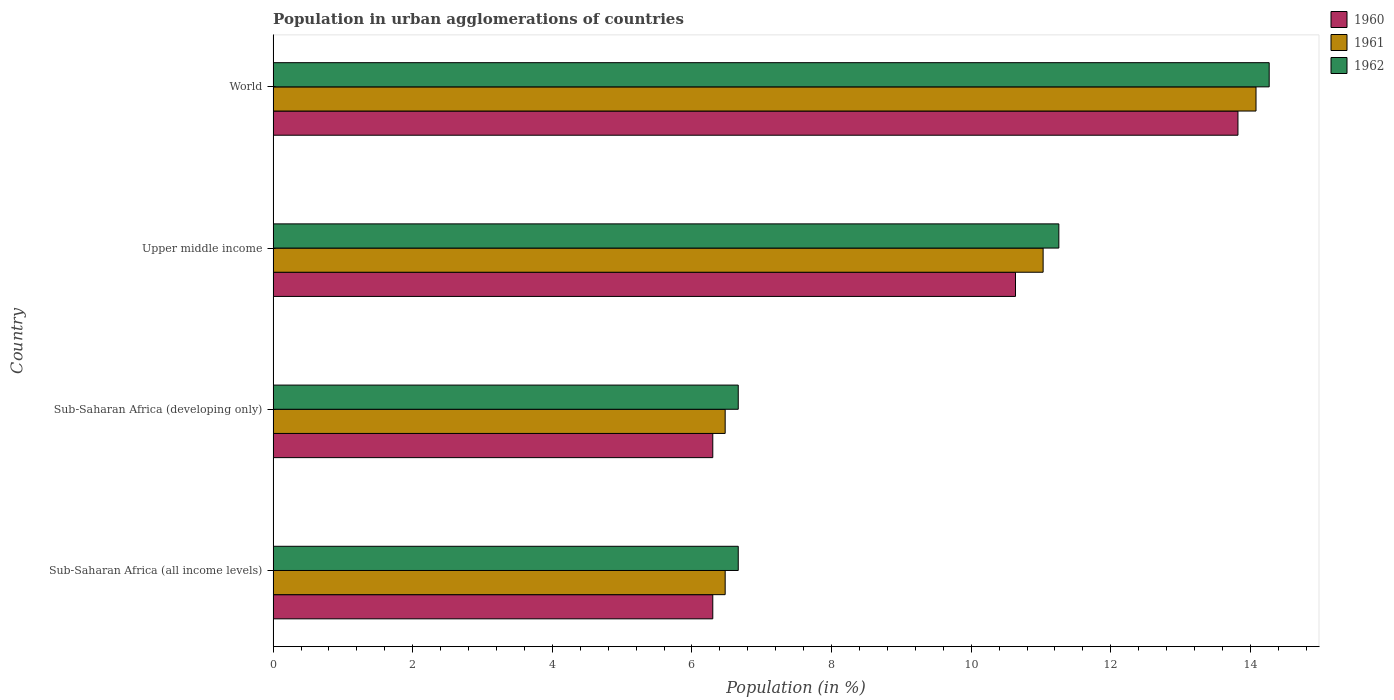How many different coloured bars are there?
Give a very brief answer. 3. How many groups of bars are there?
Ensure brevity in your answer.  4. Are the number of bars per tick equal to the number of legend labels?
Your answer should be very brief. Yes. How many bars are there on the 2nd tick from the top?
Offer a very short reply. 3. What is the label of the 4th group of bars from the top?
Give a very brief answer. Sub-Saharan Africa (all income levels). What is the percentage of population in urban agglomerations in 1961 in Sub-Saharan Africa (all income levels)?
Your answer should be compact. 6.48. Across all countries, what is the maximum percentage of population in urban agglomerations in 1961?
Ensure brevity in your answer.  14.08. Across all countries, what is the minimum percentage of population in urban agglomerations in 1960?
Provide a short and direct response. 6.3. In which country was the percentage of population in urban agglomerations in 1960 minimum?
Your answer should be compact. Sub-Saharan Africa (all income levels). What is the total percentage of population in urban agglomerations in 1961 in the graph?
Your response must be concise. 38.06. What is the difference between the percentage of population in urban agglomerations in 1961 in Sub-Saharan Africa (developing only) and that in Upper middle income?
Provide a short and direct response. -4.55. What is the difference between the percentage of population in urban agglomerations in 1961 in Upper middle income and the percentage of population in urban agglomerations in 1962 in Sub-Saharan Africa (all income levels)?
Your response must be concise. 4.37. What is the average percentage of population in urban agglomerations in 1962 per country?
Give a very brief answer. 9.71. What is the difference between the percentage of population in urban agglomerations in 1960 and percentage of population in urban agglomerations in 1962 in World?
Offer a terse response. -0.45. In how many countries, is the percentage of population in urban agglomerations in 1962 greater than 6.8 %?
Provide a succinct answer. 2. What is the ratio of the percentage of population in urban agglomerations in 1960 in Sub-Saharan Africa (all income levels) to that in Upper middle income?
Keep it short and to the point. 0.59. Is the difference between the percentage of population in urban agglomerations in 1960 in Sub-Saharan Africa (developing only) and World greater than the difference between the percentage of population in urban agglomerations in 1962 in Sub-Saharan Africa (developing only) and World?
Keep it short and to the point. Yes. What is the difference between the highest and the second highest percentage of population in urban agglomerations in 1961?
Ensure brevity in your answer.  3.05. What is the difference between the highest and the lowest percentage of population in urban agglomerations in 1961?
Make the answer very short. 7.6. Is it the case that in every country, the sum of the percentage of population in urban agglomerations in 1962 and percentage of population in urban agglomerations in 1960 is greater than the percentage of population in urban agglomerations in 1961?
Give a very brief answer. Yes. Are all the bars in the graph horizontal?
Keep it short and to the point. Yes. How many countries are there in the graph?
Make the answer very short. 4. Does the graph contain any zero values?
Offer a terse response. No. Does the graph contain grids?
Offer a very short reply. No. Where does the legend appear in the graph?
Provide a succinct answer. Top right. How many legend labels are there?
Provide a succinct answer. 3. How are the legend labels stacked?
Give a very brief answer. Vertical. What is the title of the graph?
Offer a terse response. Population in urban agglomerations of countries. Does "1979" appear as one of the legend labels in the graph?
Give a very brief answer. No. What is the label or title of the X-axis?
Give a very brief answer. Population (in %). What is the label or title of the Y-axis?
Your answer should be very brief. Country. What is the Population (in %) in 1960 in Sub-Saharan Africa (all income levels)?
Keep it short and to the point. 6.3. What is the Population (in %) of 1961 in Sub-Saharan Africa (all income levels)?
Provide a short and direct response. 6.48. What is the Population (in %) of 1962 in Sub-Saharan Africa (all income levels)?
Make the answer very short. 6.66. What is the Population (in %) in 1960 in Sub-Saharan Africa (developing only)?
Give a very brief answer. 6.3. What is the Population (in %) in 1961 in Sub-Saharan Africa (developing only)?
Your response must be concise. 6.48. What is the Population (in %) in 1962 in Sub-Saharan Africa (developing only)?
Provide a succinct answer. 6.66. What is the Population (in %) in 1960 in Upper middle income?
Provide a succinct answer. 10.63. What is the Population (in %) in 1961 in Upper middle income?
Ensure brevity in your answer.  11.03. What is the Population (in %) of 1962 in Upper middle income?
Offer a terse response. 11.26. What is the Population (in %) of 1960 in World?
Provide a succinct answer. 13.82. What is the Population (in %) of 1961 in World?
Make the answer very short. 14.08. What is the Population (in %) of 1962 in World?
Your answer should be very brief. 14.27. Across all countries, what is the maximum Population (in %) of 1960?
Your answer should be very brief. 13.82. Across all countries, what is the maximum Population (in %) of 1961?
Provide a short and direct response. 14.08. Across all countries, what is the maximum Population (in %) of 1962?
Provide a short and direct response. 14.27. Across all countries, what is the minimum Population (in %) of 1960?
Your response must be concise. 6.3. Across all countries, what is the minimum Population (in %) of 1961?
Provide a succinct answer. 6.48. Across all countries, what is the minimum Population (in %) of 1962?
Make the answer very short. 6.66. What is the total Population (in %) in 1960 in the graph?
Provide a succinct answer. 37.05. What is the total Population (in %) of 1961 in the graph?
Keep it short and to the point. 38.06. What is the total Population (in %) in 1962 in the graph?
Make the answer very short. 38.85. What is the difference between the Population (in %) in 1961 in Sub-Saharan Africa (all income levels) and that in Sub-Saharan Africa (developing only)?
Give a very brief answer. 0. What is the difference between the Population (in %) in 1962 in Sub-Saharan Africa (all income levels) and that in Sub-Saharan Africa (developing only)?
Ensure brevity in your answer.  0. What is the difference between the Population (in %) in 1960 in Sub-Saharan Africa (all income levels) and that in Upper middle income?
Ensure brevity in your answer.  -4.34. What is the difference between the Population (in %) in 1961 in Sub-Saharan Africa (all income levels) and that in Upper middle income?
Provide a short and direct response. -4.55. What is the difference between the Population (in %) of 1962 in Sub-Saharan Africa (all income levels) and that in Upper middle income?
Provide a succinct answer. -4.59. What is the difference between the Population (in %) of 1960 in Sub-Saharan Africa (all income levels) and that in World?
Provide a succinct answer. -7.52. What is the difference between the Population (in %) of 1961 in Sub-Saharan Africa (all income levels) and that in World?
Your answer should be very brief. -7.6. What is the difference between the Population (in %) of 1962 in Sub-Saharan Africa (all income levels) and that in World?
Keep it short and to the point. -7.61. What is the difference between the Population (in %) in 1960 in Sub-Saharan Africa (developing only) and that in Upper middle income?
Provide a succinct answer. -4.34. What is the difference between the Population (in %) of 1961 in Sub-Saharan Africa (developing only) and that in Upper middle income?
Provide a succinct answer. -4.55. What is the difference between the Population (in %) of 1962 in Sub-Saharan Africa (developing only) and that in Upper middle income?
Ensure brevity in your answer.  -4.59. What is the difference between the Population (in %) of 1960 in Sub-Saharan Africa (developing only) and that in World?
Offer a terse response. -7.52. What is the difference between the Population (in %) of 1961 in Sub-Saharan Africa (developing only) and that in World?
Your answer should be very brief. -7.6. What is the difference between the Population (in %) of 1962 in Sub-Saharan Africa (developing only) and that in World?
Your answer should be very brief. -7.61. What is the difference between the Population (in %) of 1960 in Upper middle income and that in World?
Provide a short and direct response. -3.19. What is the difference between the Population (in %) of 1961 in Upper middle income and that in World?
Keep it short and to the point. -3.05. What is the difference between the Population (in %) of 1962 in Upper middle income and that in World?
Offer a very short reply. -3.01. What is the difference between the Population (in %) of 1960 in Sub-Saharan Africa (all income levels) and the Population (in %) of 1961 in Sub-Saharan Africa (developing only)?
Provide a succinct answer. -0.18. What is the difference between the Population (in %) in 1960 in Sub-Saharan Africa (all income levels) and the Population (in %) in 1962 in Sub-Saharan Africa (developing only)?
Offer a terse response. -0.36. What is the difference between the Population (in %) of 1961 in Sub-Saharan Africa (all income levels) and the Population (in %) of 1962 in Sub-Saharan Africa (developing only)?
Offer a very short reply. -0.19. What is the difference between the Population (in %) in 1960 in Sub-Saharan Africa (all income levels) and the Population (in %) in 1961 in Upper middle income?
Give a very brief answer. -4.73. What is the difference between the Population (in %) of 1960 in Sub-Saharan Africa (all income levels) and the Population (in %) of 1962 in Upper middle income?
Make the answer very short. -4.96. What is the difference between the Population (in %) in 1961 in Sub-Saharan Africa (all income levels) and the Population (in %) in 1962 in Upper middle income?
Your answer should be very brief. -4.78. What is the difference between the Population (in %) of 1960 in Sub-Saharan Africa (all income levels) and the Population (in %) of 1961 in World?
Offer a very short reply. -7.78. What is the difference between the Population (in %) of 1960 in Sub-Saharan Africa (all income levels) and the Population (in %) of 1962 in World?
Your response must be concise. -7.97. What is the difference between the Population (in %) in 1961 in Sub-Saharan Africa (all income levels) and the Population (in %) in 1962 in World?
Offer a terse response. -7.79. What is the difference between the Population (in %) in 1960 in Sub-Saharan Africa (developing only) and the Population (in %) in 1961 in Upper middle income?
Your response must be concise. -4.73. What is the difference between the Population (in %) in 1960 in Sub-Saharan Africa (developing only) and the Population (in %) in 1962 in Upper middle income?
Provide a short and direct response. -4.96. What is the difference between the Population (in %) of 1961 in Sub-Saharan Africa (developing only) and the Population (in %) of 1962 in Upper middle income?
Keep it short and to the point. -4.78. What is the difference between the Population (in %) in 1960 in Sub-Saharan Africa (developing only) and the Population (in %) in 1961 in World?
Give a very brief answer. -7.78. What is the difference between the Population (in %) of 1960 in Sub-Saharan Africa (developing only) and the Population (in %) of 1962 in World?
Provide a short and direct response. -7.97. What is the difference between the Population (in %) in 1961 in Sub-Saharan Africa (developing only) and the Population (in %) in 1962 in World?
Offer a very short reply. -7.79. What is the difference between the Population (in %) of 1960 in Upper middle income and the Population (in %) of 1961 in World?
Provide a short and direct response. -3.45. What is the difference between the Population (in %) in 1960 in Upper middle income and the Population (in %) in 1962 in World?
Ensure brevity in your answer.  -3.63. What is the difference between the Population (in %) in 1961 in Upper middle income and the Population (in %) in 1962 in World?
Ensure brevity in your answer.  -3.24. What is the average Population (in %) of 1960 per country?
Ensure brevity in your answer.  9.26. What is the average Population (in %) of 1961 per country?
Your response must be concise. 9.52. What is the average Population (in %) in 1962 per country?
Ensure brevity in your answer.  9.71. What is the difference between the Population (in %) in 1960 and Population (in %) in 1961 in Sub-Saharan Africa (all income levels)?
Give a very brief answer. -0.18. What is the difference between the Population (in %) in 1960 and Population (in %) in 1962 in Sub-Saharan Africa (all income levels)?
Offer a terse response. -0.36. What is the difference between the Population (in %) in 1961 and Population (in %) in 1962 in Sub-Saharan Africa (all income levels)?
Offer a very short reply. -0.19. What is the difference between the Population (in %) in 1960 and Population (in %) in 1961 in Sub-Saharan Africa (developing only)?
Offer a very short reply. -0.18. What is the difference between the Population (in %) of 1960 and Population (in %) of 1962 in Sub-Saharan Africa (developing only)?
Keep it short and to the point. -0.36. What is the difference between the Population (in %) in 1961 and Population (in %) in 1962 in Sub-Saharan Africa (developing only)?
Your response must be concise. -0.19. What is the difference between the Population (in %) of 1960 and Population (in %) of 1961 in Upper middle income?
Provide a short and direct response. -0.4. What is the difference between the Population (in %) of 1960 and Population (in %) of 1962 in Upper middle income?
Provide a short and direct response. -0.62. What is the difference between the Population (in %) in 1961 and Population (in %) in 1962 in Upper middle income?
Your response must be concise. -0.23. What is the difference between the Population (in %) of 1960 and Population (in %) of 1961 in World?
Your answer should be compact. -0.26. What is the difference between the Population (in %) in 1960 and Population (in %) in 1962 in World?
Give a very brief answer. -0.45. What is the difference between the Population (in %) in 1961 and Population (in %) in 1962 in World?
Provide a succinct answer. -0.19. What is the ratio of the Population (in %) in 1960 in Sub-Saharan Africa (all income levels) to that in Sub-Saharan Africa (developing only)?
Your response must be concise. 1. What is the ratio of the Population (in %) in 1960 in Sub-Saharan Africa (all income levels) to that in Upper middle income?
Your response must be concise. 0.59. What is the ratio of the Population (in %) of 1961 in Sub-Saharan Africa (all income levels) to that in Upper middle income?
Provide a succinct answer. 0.59. What is the ratio of the Population (in %) of 1962 in Sub-Saharan Africa (all income levels) to that in Upper middle income?
Ensure brevity in your answer.  0.59. What is the ratio of the Population (in %) in 1960 in Sub-Saharan Africa (all income levels) to that in World?
Keep it short and to the point. 0.46. What is the ratio of the Population (in %) of 1961 in Sub-Saharan Africa (all income levels) to that in World?
Offer a terse response. 0.46. What is the ratio of the Population (in %) in 1962 in Sub-Saharan Africa (all income levels) to that in World?
Your response must be concise. 0.47. What is the ratio of the Population (in %) in 1960 in Sub-Saharan Africa (developing only) to that in Upper middle income?
Ensure brevity in your answer.  0.59. What is the ratio of the Population (in %) of 1961 in Sub-Saharan Africa (developing only) to that in Upper middle income?
Offer a terse response. 0.59. What is the ratio of the Population (in %) in 1962 in Sub-Saharan Africa (developing only) to that in Upper middle income?
Ensure brevity in your answer.  0.59. What is the ratio of the Population (in %) in 1960 in Sub-Saharan Africa (developing only) to that in World?
Your response must be concise. 0.46. What is the ratio of the Population (in %) in 1961 in Sub-Saharan Africa (developing only) to that in World?
Provide a short and direct response. 0.46. What is the ratio of the Population (in %) of 1962 in Sub-Saharan Africa (developing only) to that in World?
Offer a terse response. 0.47. What is the ratio of the Population (in %) of 1960 in Upper middle income to that in World?
Offer a very short reply. 0.77. What is the ratio of the Population (in %) of 1961 in Upper middle income to that in World?
Provide a short and direct response. 0.78. What is the ratio of the Population (in %) of 1962 in Upper middle income to that in World?
Provide a succinct answer. 0.79. What is the difference between the highest and the second highest Population (in %) in 1960?
Give a very brief answer. 3.19. What is the difference between the highest and the second highest Population (in %) in 1961?
Ensure brevity in your answer.  3.05. What is the difference between the highest and the second highest Population (in %) of 1962?
Make the answer very short. 3.01. What is the difference between the highest and the lowest Population (in %) in 1960?
Make the answer very short. 7.52. What is the difference between the highest and the lowest Population (in %) in 1961?
Your response must be concise. 7.6. What is the difference between the highest and the lowest Population (in %) of 1962?
Give a very brief answer. 7.61. 